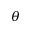<formula> <loc_0><loc_0><loc_500><loc_500>\theta</formula> 